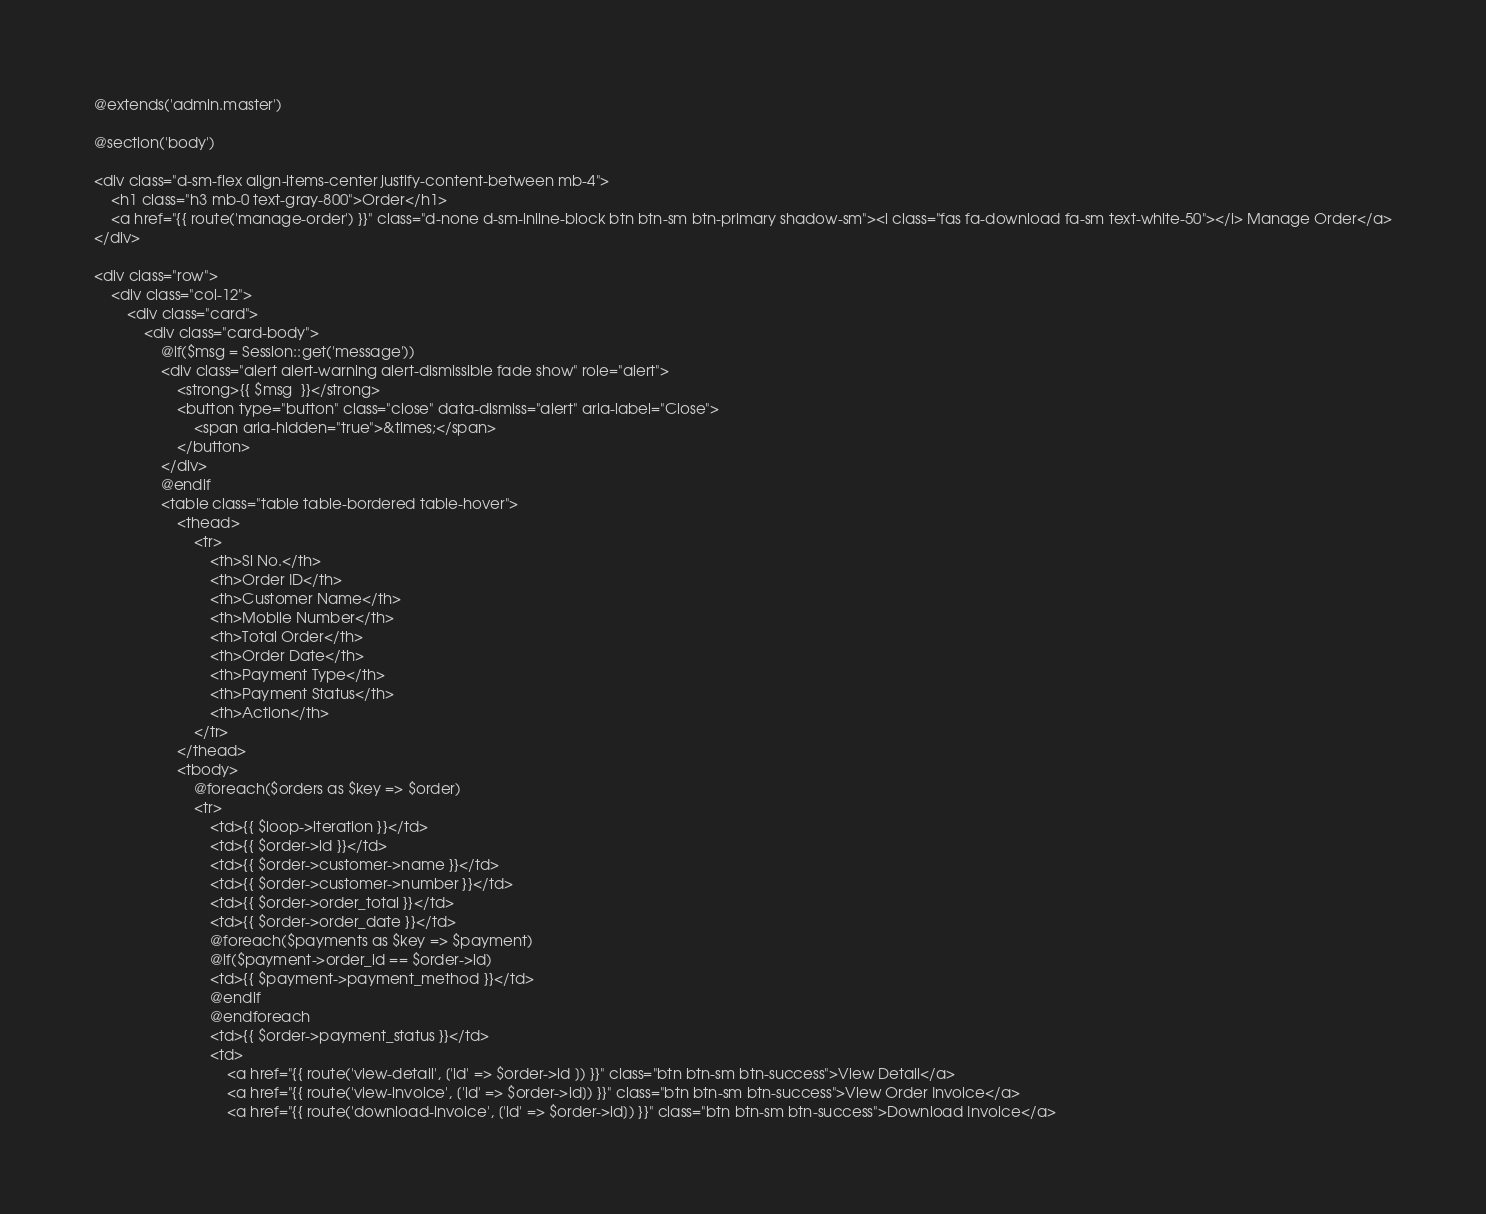Convert code to text. <code><loc_0><loc_0><loc_500><loc_500><_PHP_>@extends('admin.master')

@section('body')

<div class="d-sm-flex align-items-center justify-content-between mb-4">
    <h1 class="h3 mb-0 text-gray-800">Order</h1>
    <a href="{{ route('manage-order') }}" class="d-none d-sm-inline-block btn btn-sm btn-primary shadow-sm"><i class="fas fa-download fa-sm text-white-50"></i> Manage Order</a>
</div>

<div class="row">
    <div class="col-12">
        <div class="card">
            <div class="card-body">
                @if($msg = Session::get('message'))
                <div class="alert alert-warning alert-dismissible fade show" role="alert">
                    <strong>{{ $msg  }}</strong>
                    <button type="button" class="close" data-dismiss="alert" aria-label="Close">
                        <span aria-hidden="true">&times;</span>
                    </button>
                </div>
                @endif
                <table class="table table-bordered table-hover">
                    <thead>
                        <tr>
                            <th>Sl No.</th>
                            <th>Order ID</th>
                            <th>Customer Name</th>
                            <th>Mobile Number</th>
                            <th>Total Order</th>
                            <th>Order Date</th>
                            <th>Payment Type</th>
                            <th>Payment Status</th>
                            <th>Action</th>
                        </tr>
                    </thead>
                    <tbody>
                        @foreach($orders as $key => $order)
                        <tr>
                            <td>{{ $loop->iteration }}</td>
                            <td>{{ $order->id }}</td>
                            <td>{{ $order->customer->name }}</td>
                            <td>{{ $order->customer->number }}</td>
                            <td>{{ $order->order_total }}</td>
                            <td>{{ $order->order_date }}</td>
                            @foreach($payments as $key => $payment)
                            @if($payment->order_id == $order->id)
                            <td>{{ $payment->payment_method }}</td>
                            @endif
                            @endforeach
                            <td>{{ $order->payment_status }}</td>
                            <td>
                                <a href="{{ route('view-detail', ['id' => $order->id ]) }}" class="btn btn-sm btn-success">View Detail</a>
                                <a href="{{ route('view-invoice', ['id' => $order->id]) }}" class="btn btn-sm btn-success">View Order Invoice</a>
                                <a href="{{ route('download-invoice', ['id' => $order->id]) }}" class="btn btn-sm btn-success">Download Invoice</a></code> 